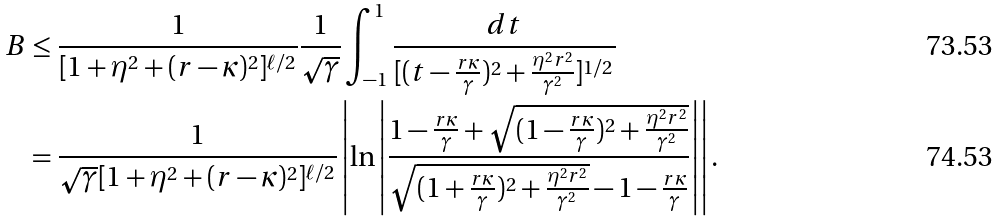<formula> <loc_0><loc_0><loc_500><loc_500>B & \leq \frac { 1 } { [ 1 + \eta ^ { 2 } + ( r - \kappa ) ^ { 2 } ] ^ { \ell / 2 } } \frac { 1 } { \sqrt { \gamma } } \int _ { - 1 } ^ { 1 } \frac { d t } { [ ( t - \frac { r \kappa } { \gamma } ) ^ { 2 } + \frac { \eta ^ { 2 } r ^ { 2 } } { \gamma ^ { 2 } } ] ^ { 1 / 2 } } \\ & = \frac { 1 } { \sqrt { \gamma } [ 1 + \eta ^ { 2 } + ( r - \kappa ) ^ { 2 } ] ^ { \ell / 2 } } \left | \ln \left | \frac { 1 - \frac { r \kappa } { \gamma } + \sqrt { ( 1 - \frac { r \kappa } { \gamma } ) ^ { 2 } + \frac { \eta ^ { 2 } r ^ { 2 } } { \gamma ^ { 2 } } } } { \sqrt { ( 1 + \frac { r \kappa } { \gamma } ) ^ { 2 } + \frac { \eta ^ { 2 } r ^ { 2 } } { \gamma ^ { 2 } } } - 1 - \frac { r \kappa } { \gamma } } \right | \right | .</formula> 